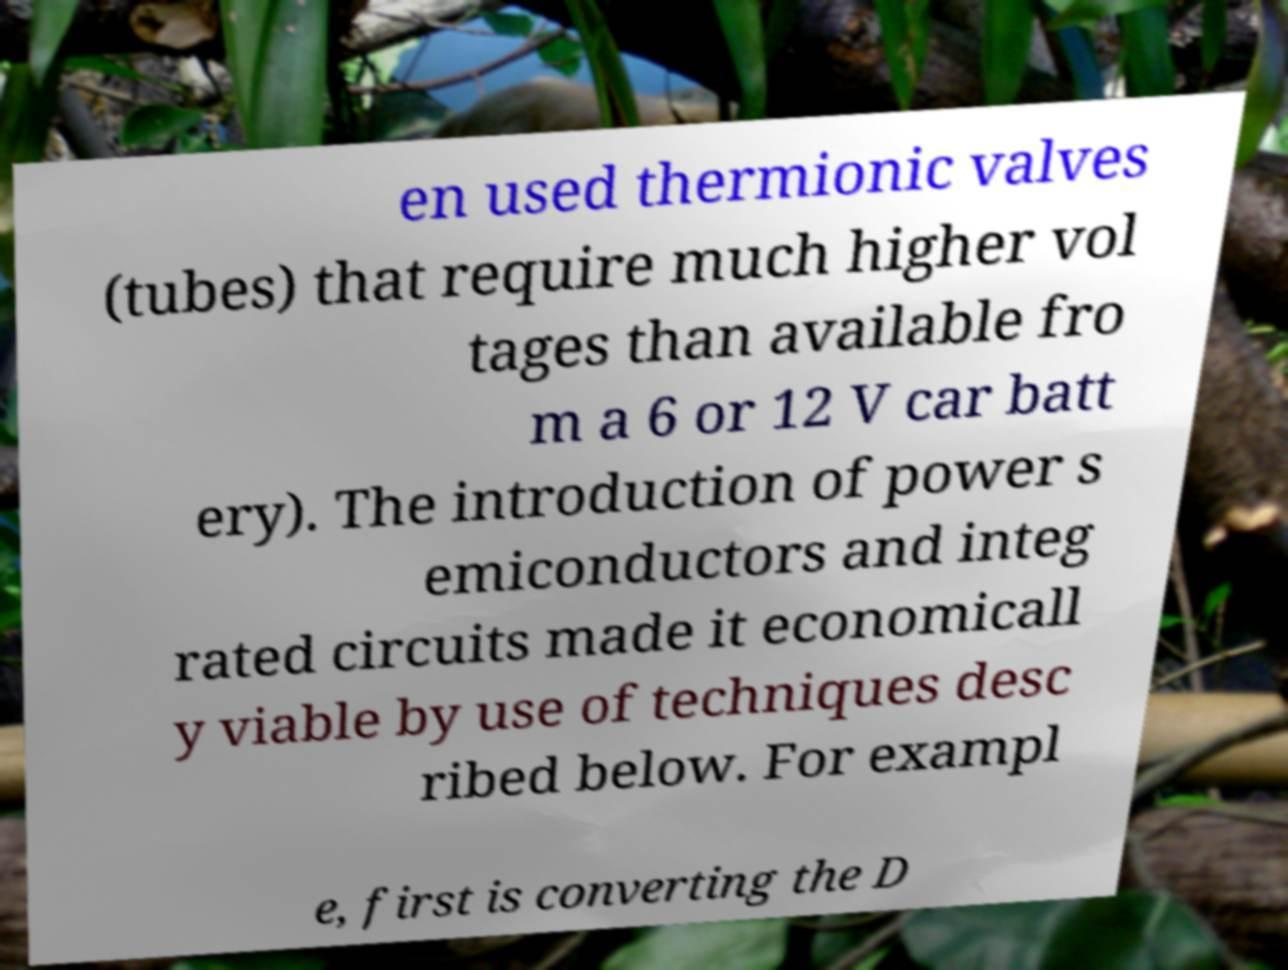What messages or text are displayed in this image? I need them in a readable, typed format. en used thermionic valves (tubes) that require much higher vol tages than available fro m a 6 or 12 V car batt ery). The introduction of power s emiconductors and integ rated circuits made it economicall y viable by use of techniques desc ribed below. For exampl e, first is converting the D 